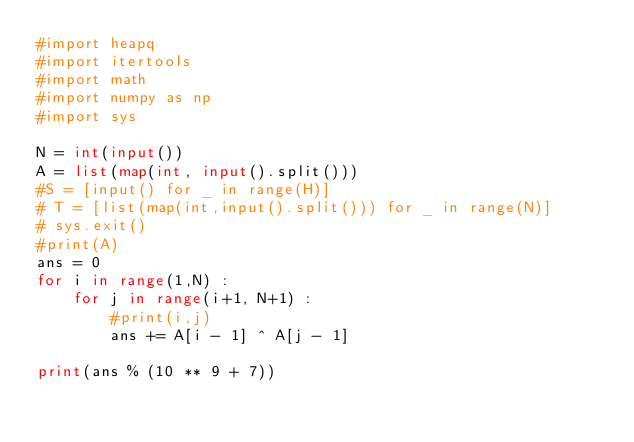Convert code to text. <code><loc_0><loc_0><loc_500><loc_500><_Python_>#import heapq
#import itertools
#import math
#import numpy as np
#import sys

N = int(input())
A = list(map(int, input().split()))
#S = [input() for _ in range(H)]
# T = [list(map(int,input().split())) for _ in range(N)]
# sys.exit()
#print(A)
ans = 0
for i in range(1,N) :
    for j in range(i+1, N+1) :
        #print(i,j)
        ans += A[i - 1] ^ A[j - 1]

print(ans % (10 ** 9 + 7))</code> 